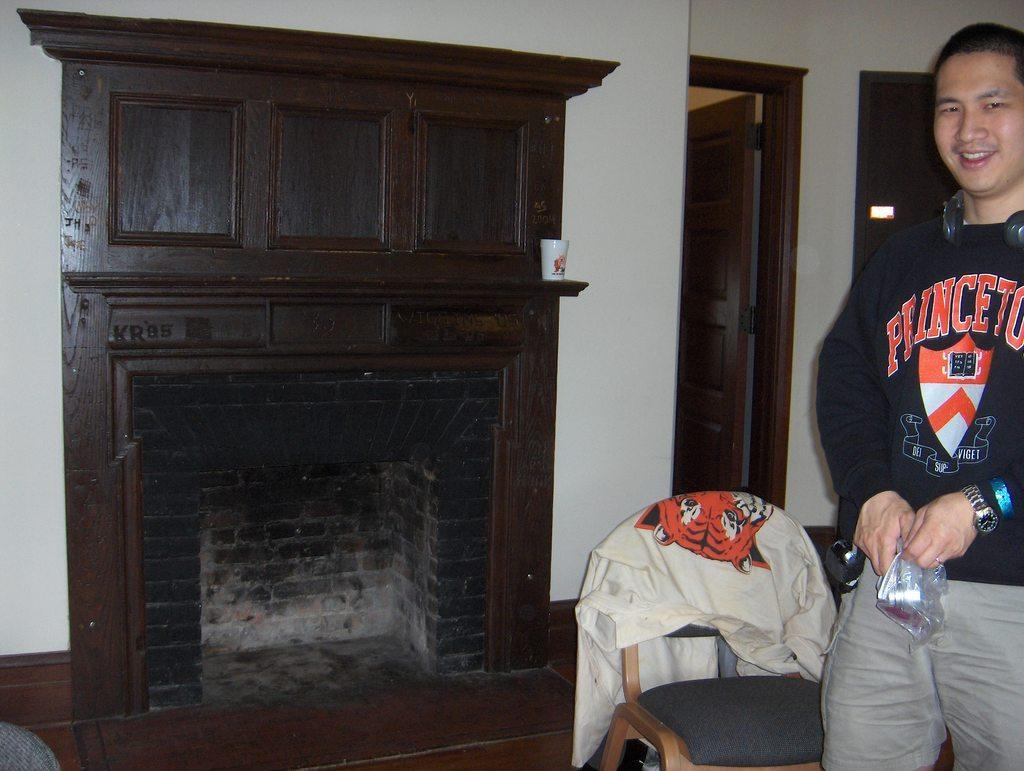How would you summarize this image in a sentence or two? In this image we can see a person standing and holding an object. Beside a person we can see a chair with a cloth. In the background, we can see the wall with door and cupboard. 